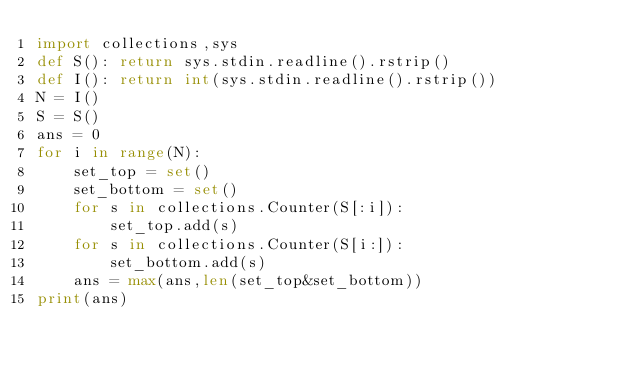<code> <loc_0><loc_0><loc_500><loc_500><_Python_>import collections,sys
def S(): return sys.stdin.readline().rstrip()
def I(): return int(sys.stdin.readline().rstrip())
N = I()
S = S()
ans = 0
for i in range(N):
    set_top = set()
    set_bottom = set()
    for s in collections.Counter(S[:i]):
        set_top.add(s)
    for s in collections.Counter(S[i:]):
        set_bottom.add(s)
    ans = max(ans,len(set_top&set_bottom))
print(ans)
</code> 